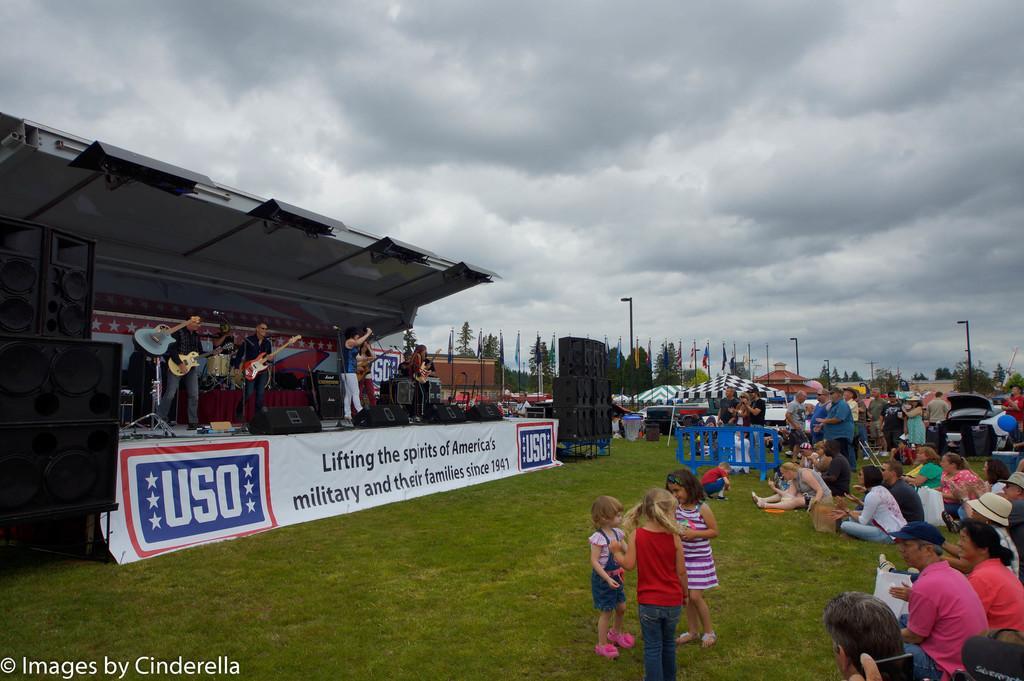In one or two sentences, can you explain what this image depicts? In this image it looks like it is a music concert. There are few people playing the guitar while the other are singing with the mic on the stage. In front of them there are spectators sitting on the ground and watching them. At the top there is sky. In the background there are tents and flags one beside the other. On the ground there are fewer kids playing. On the left side there are speakers. 